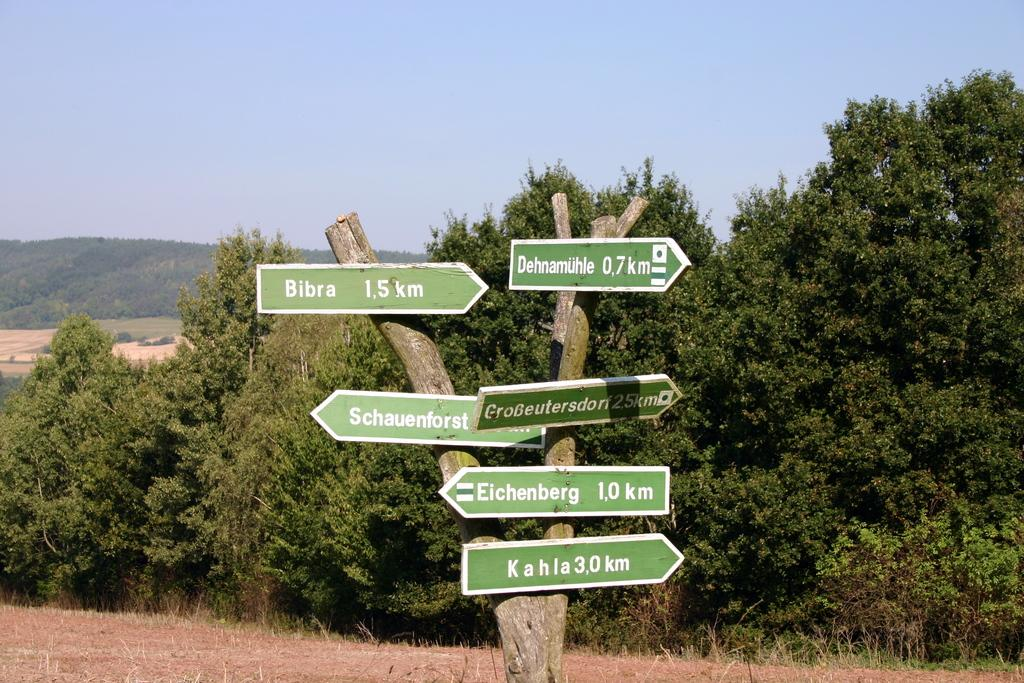<image>
Summarize the visual content of the image. A tree covered in directional signs, one of which is for Bibra 1.5km to the right. 